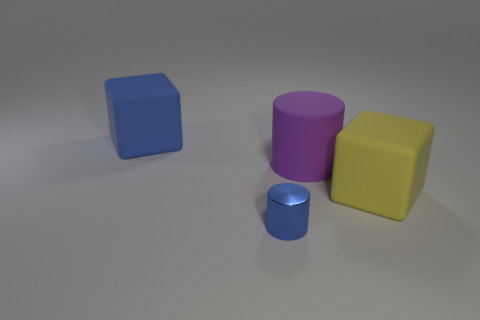Subtract all green cylinders. Subtract all purple blocks. How many cylinders are left? 2 Add 3 blue blocks. How many objects exist? 7 Add 4 matte cubes. How many matte cubes exist? 6 Subtract 0 green cylinders. How many objects are left? 4 Subtract all blue cylinders. Subtract all large blue matte things. How many objects are left? 2 Add 1 big blue matte things. How many big blue matte things are left? 2 